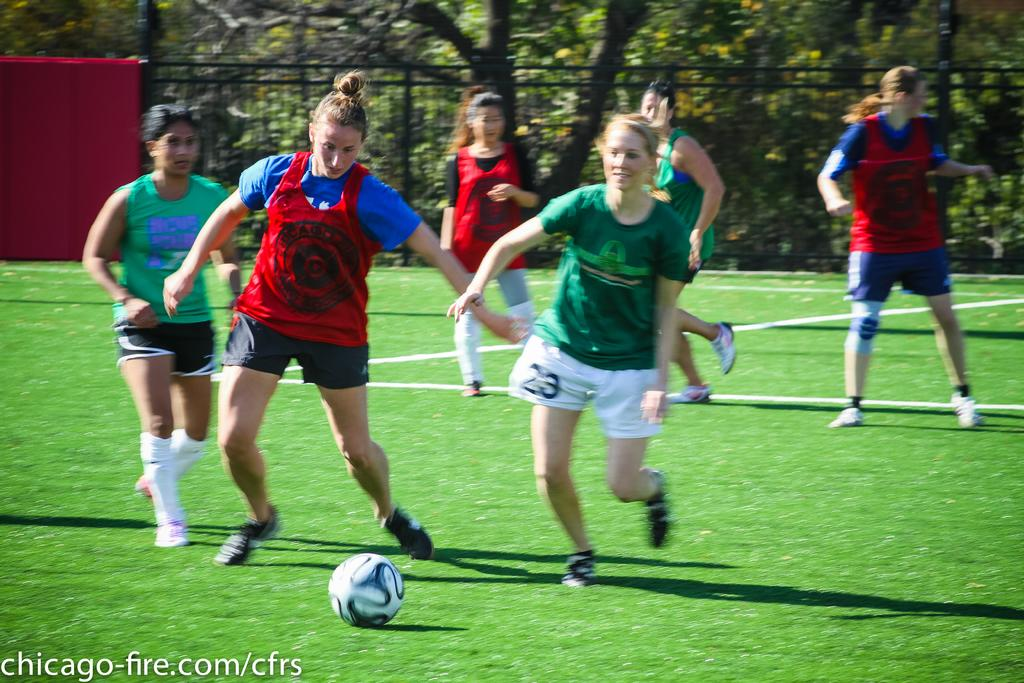<image>
Describe the image concisely. A group of girls are playing soccer on a field with number 23 going after the ball. 